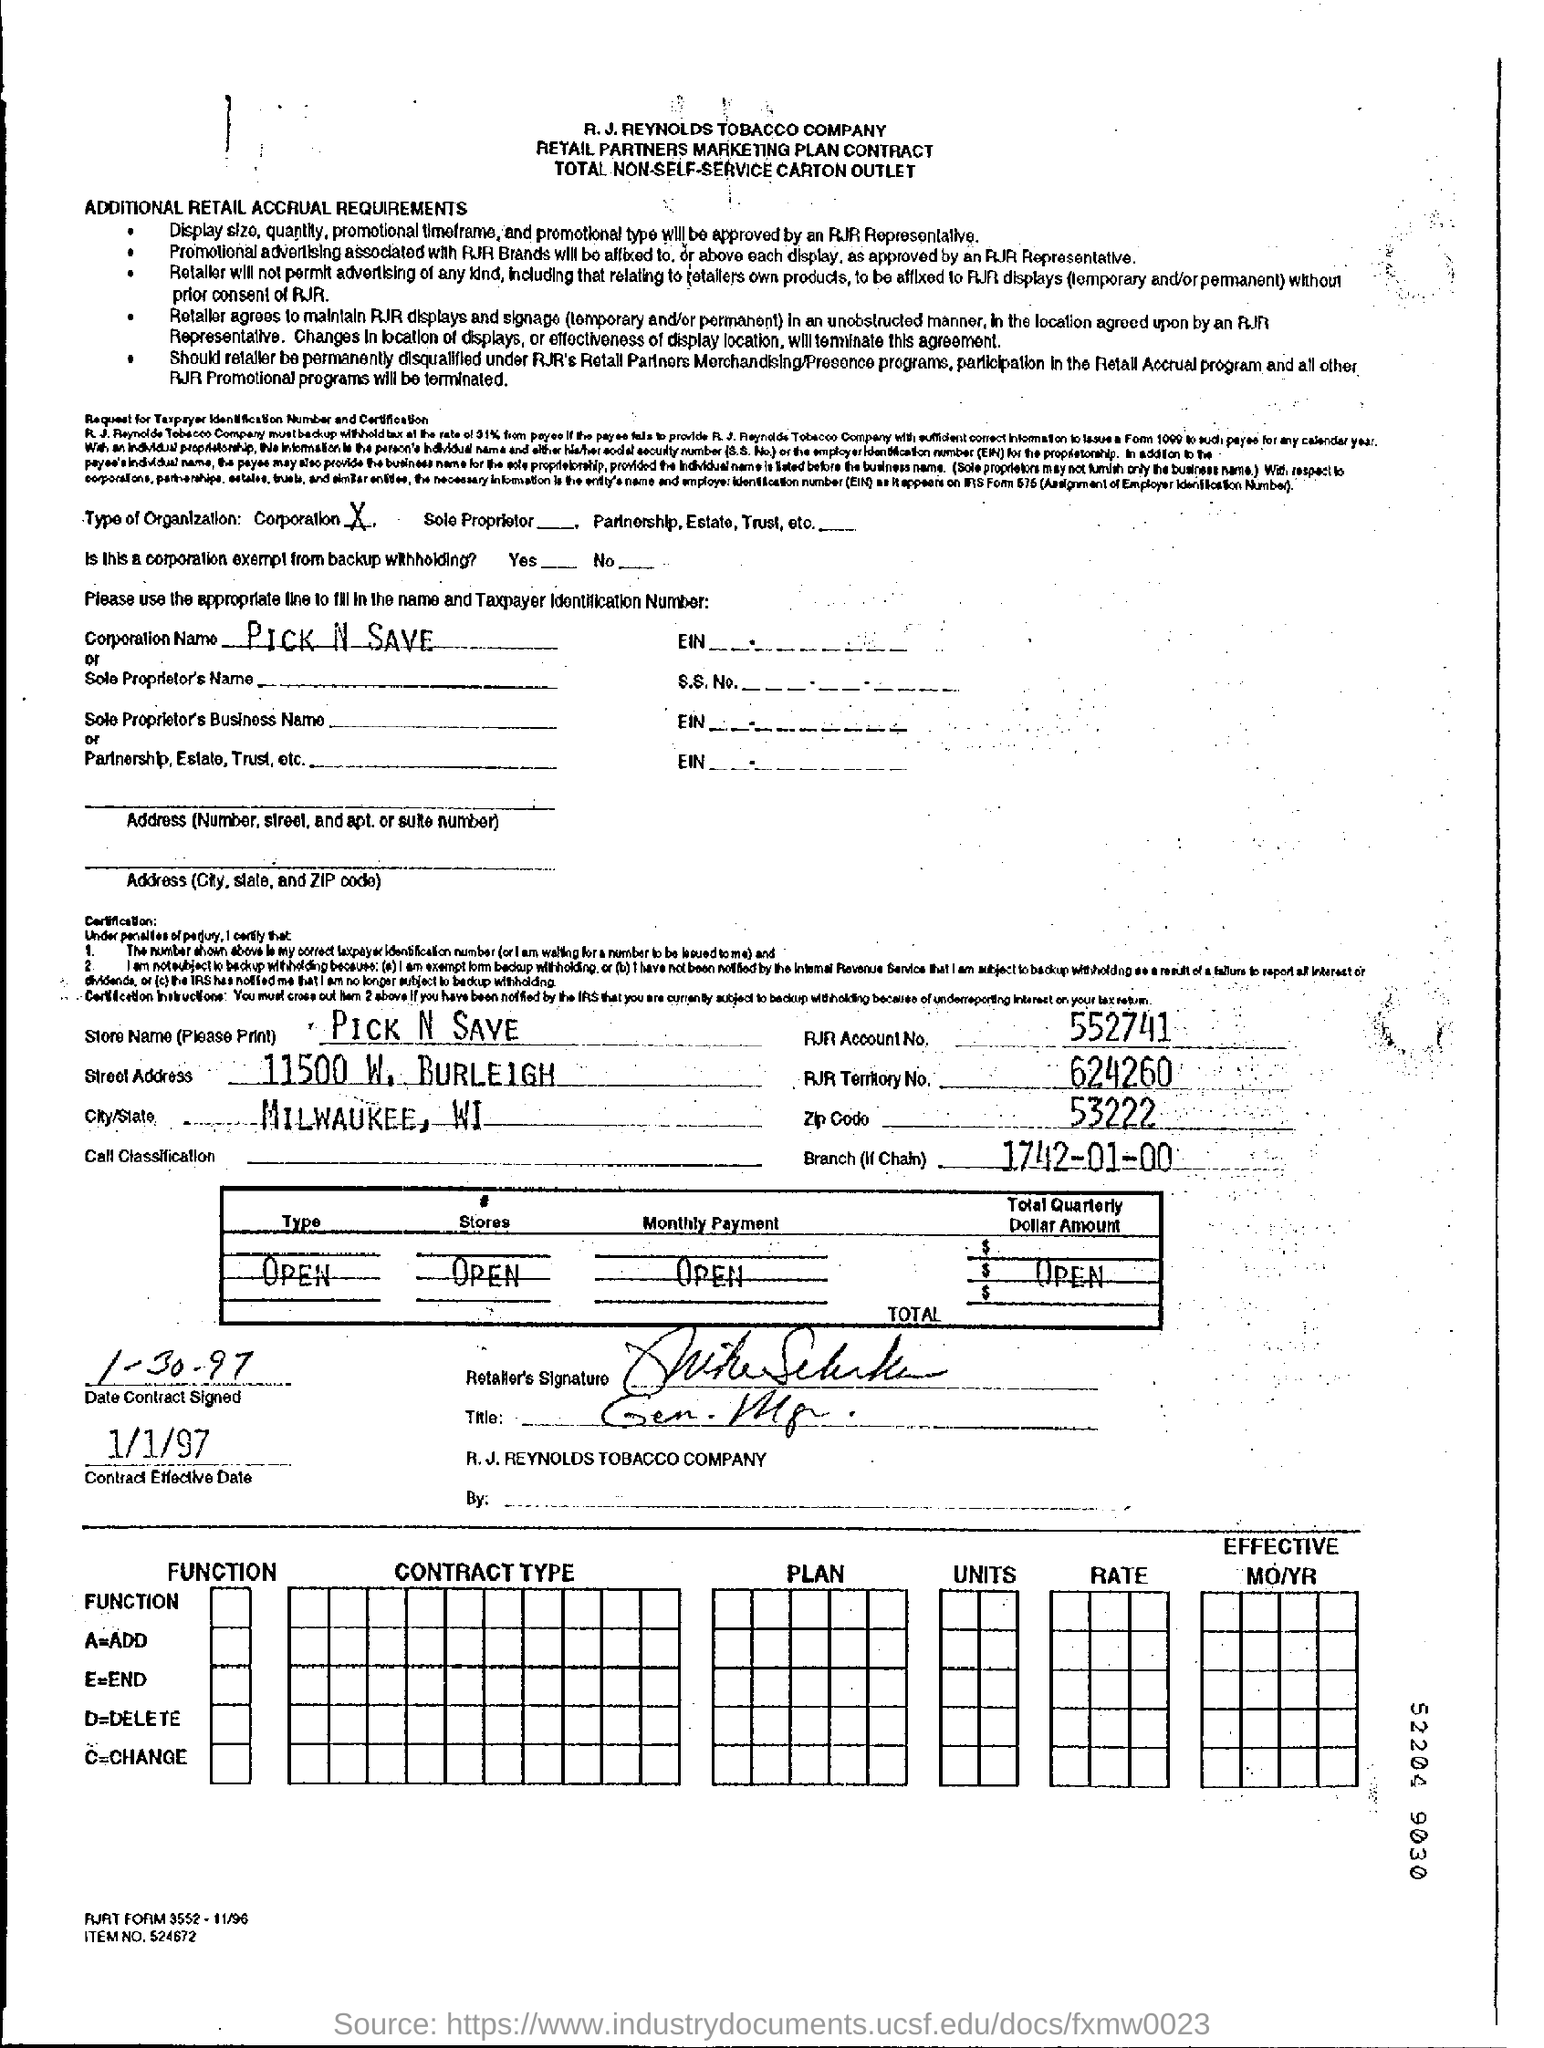Specify some key components in this picture. The Store Name mentioned in the form is PICK 'N SAVE. The RJR account number given in the form is 552741... The zip code is 53222. Pick 'n Save" is the name of a corporation. 